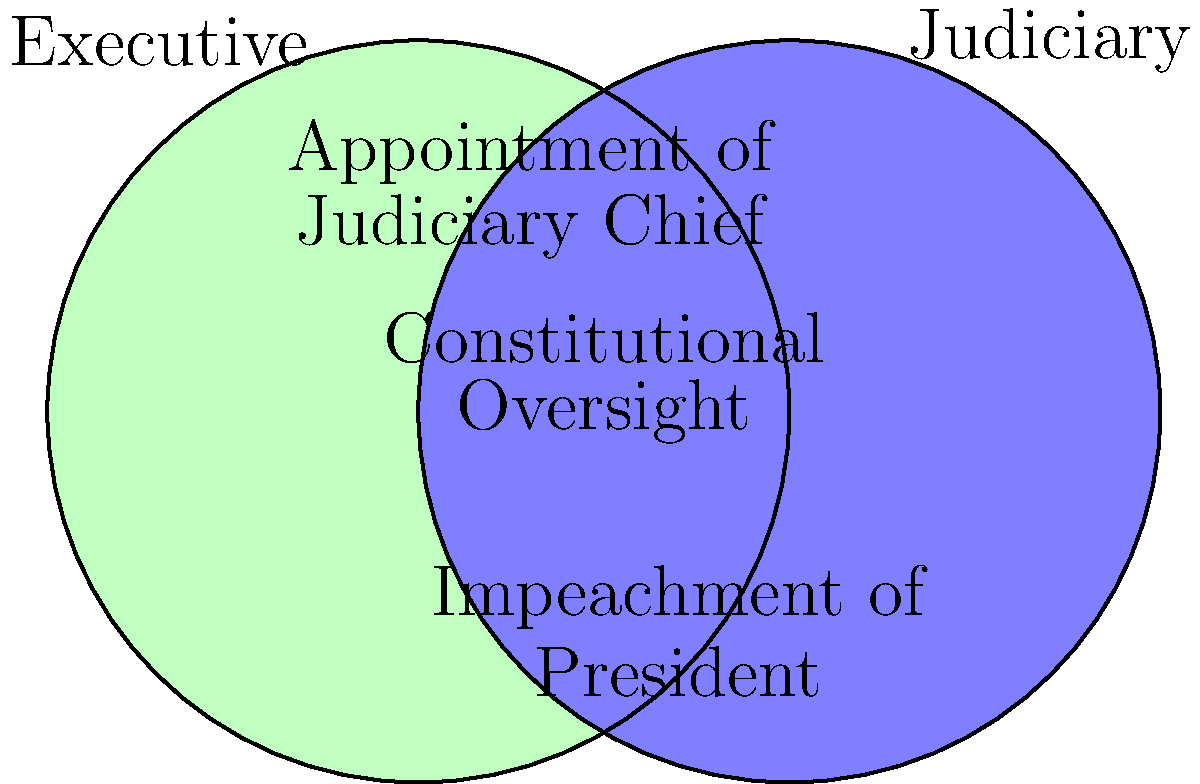Based on the Venn diagram illustrating the checks and balances between Iran's executive and judiciary branches, which power belongs exclusively to the judiciary and serves as a check on the executive branch? To answer this question, let's analyze the Venn diagram step-by-step:

1. The diagram shows two overlapping circles representing the Executive and Judiciary branches of Iran's government.

2. In the left circle (Executive):
   - We see "Appointment of Judiciary Chief" which is a power of the executive branch.

3. In the overlapping area:
   - We see "Constitutional Oversight" which is a shared responsibility between both branches.

4. In the right circle (Judiciary):
   - We see "Impeachment of President" which is a power exclusive to the judiciary branch.

5. The question asks for a power that belongs exclusively to the judiciary and serves as a check on the executive branch.

6. The impeachment of the President fits this criteria perfectly:
   - It is listed only in the Judiciary circle, indicating it's an exclusive power.
   - It directly affects the executive branch (the President), serving as a check on executive power.

Therefore, the power that belongs exclusively to the judiciary and serves as a check on the executive branch is the impeachment of the President.
Answer: Impeachment of the President 